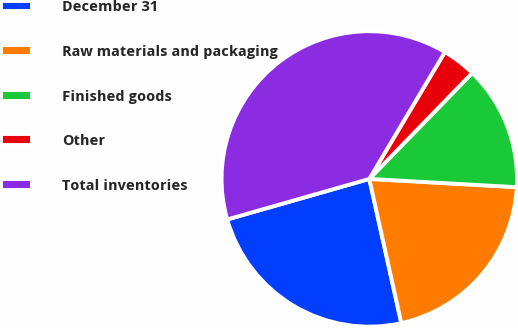Convert chart to OTSL. <chart><loc_0><loc_0><loc_500><loc_500><pie_chart><fcel>December 31<fcel>Raw materials and packaging<fcel>Finished goods<fcel>Other<fcel>Total inventories<nl><fcel>24.05%<fcel>20.63%<fcel>13.62%<fcel>3.72%<fcel>37.97%<nl></chart> 